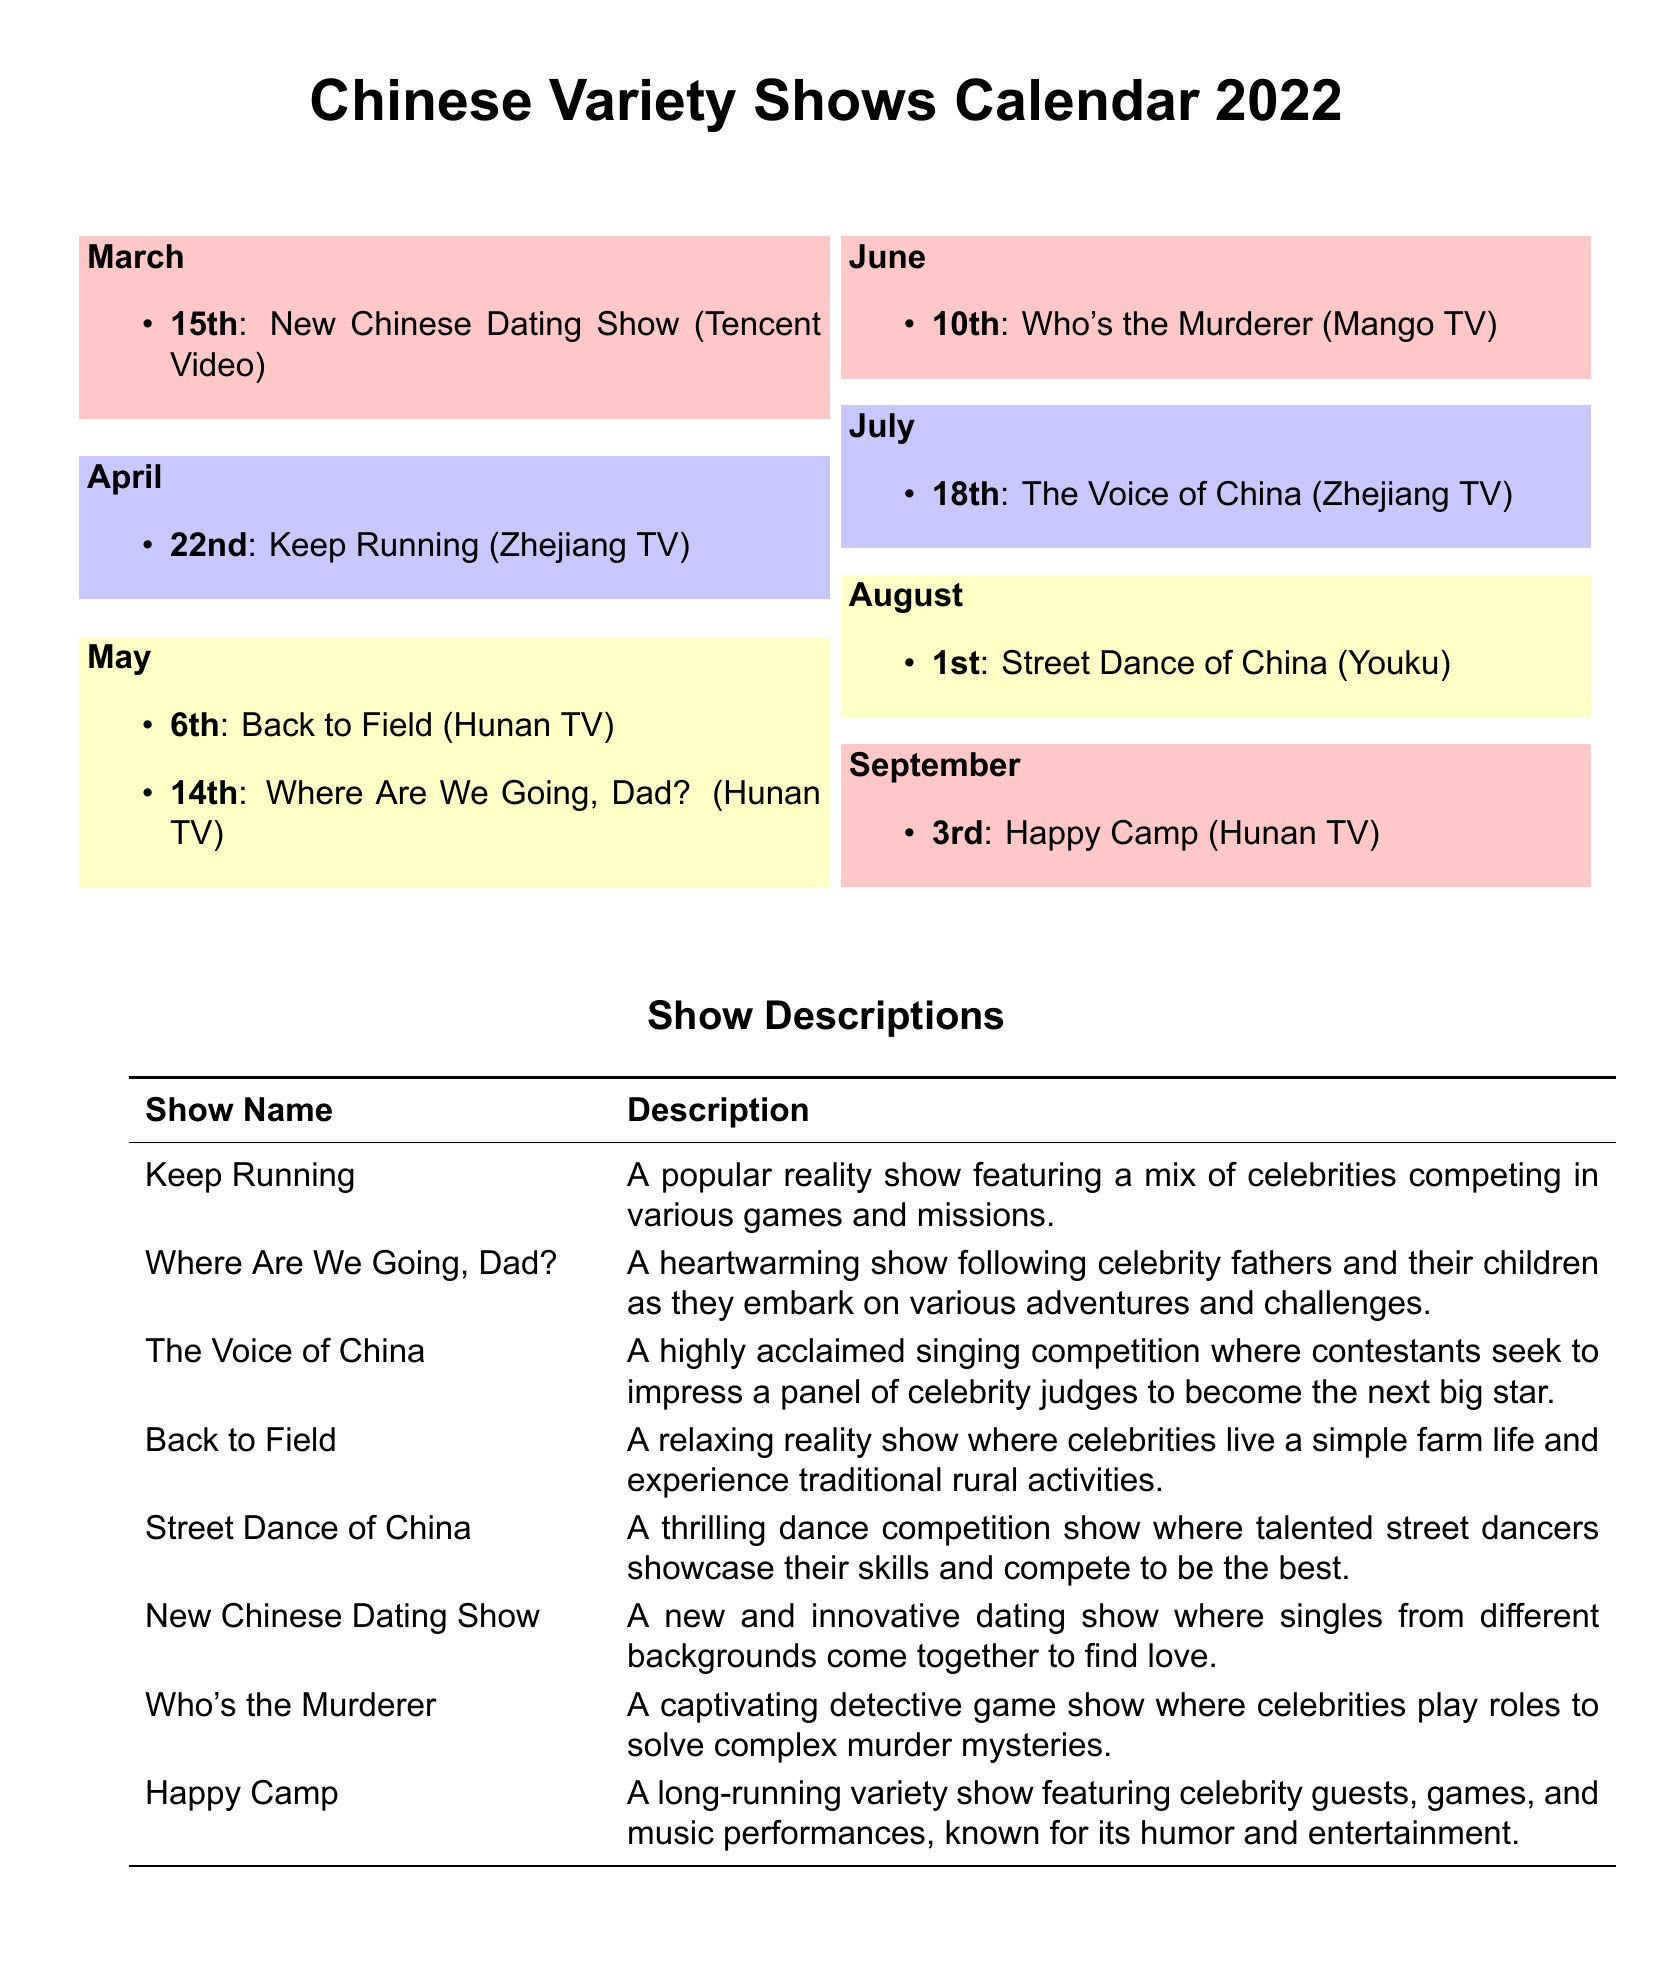What is the premiere date for the New Chinese Dating Show? The premiere date mentioned in the document is the 15th of March.
Answer: 15th Which show premieres on April 22nd? The show that premieres on April 22nd as per the document is Keep Running.
Answer: Keep Running How many shows are premiering in May? Based on the document, there are two shows mentioned for May, which are Back to Field and Where Are We Going, Dad?.
Answer: 2 What network airs the show Who's the Murderer? The document states that Who's the Murderer is aired on Mango TV.
Answer: Mango TV Which show is described as a dance competition? The show characterized as a dance competition is Street Dance of China.
Answer: Street Dance of China What type of show is Happy Camp? Happy Camp is described in the document as a long-running variety show.
Answer: variety show Which month has the premiere of The Voice of China? The document lists July as the month for the premiere of The Voice of China.
Answer: July Which variety show features celebrity fathers and their children? The show that features celebrity fathers and their children is Where Are We Going, Dad?.
Answer: Where Are We Going, Dad? 